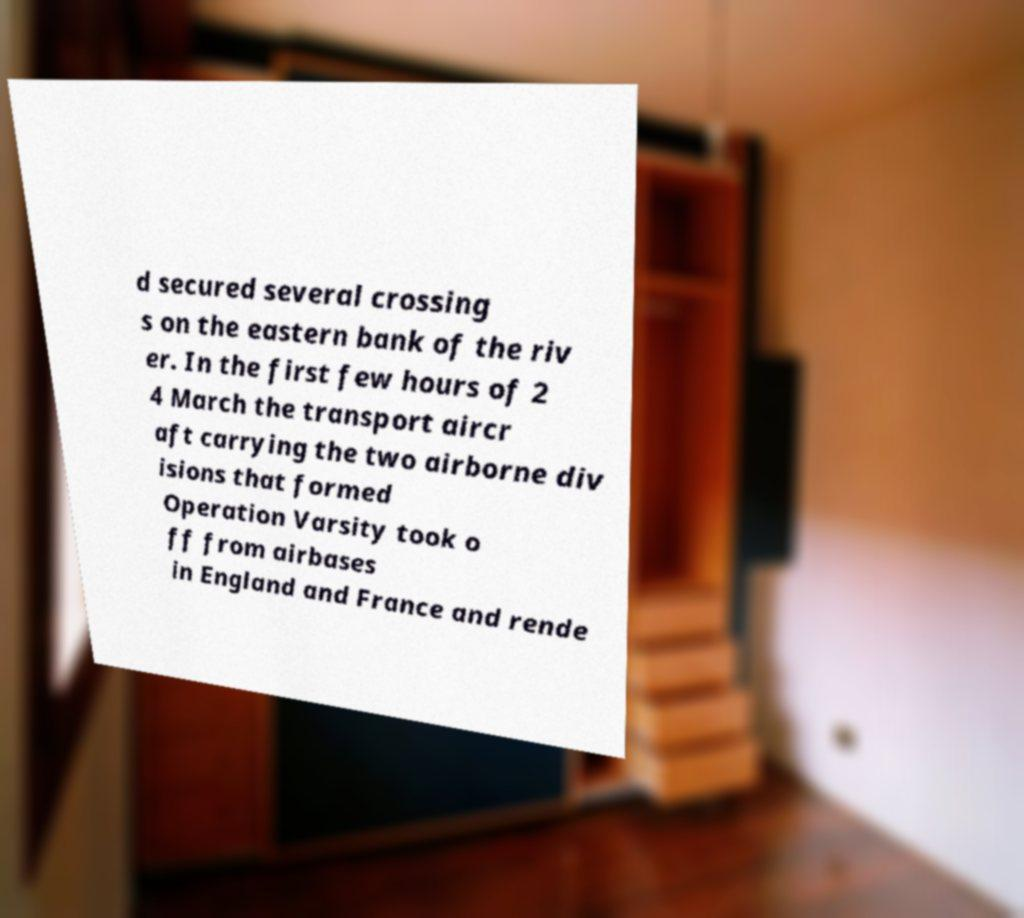Could you extract and type out the text from this image? d secured several crossing s on the eastern bank of the riv er. In the first few hours of 2 4 March the transport aircr aft carrying the two airborne div isions that formed Operation Varsity took o ff from airbases in England and France and rende 